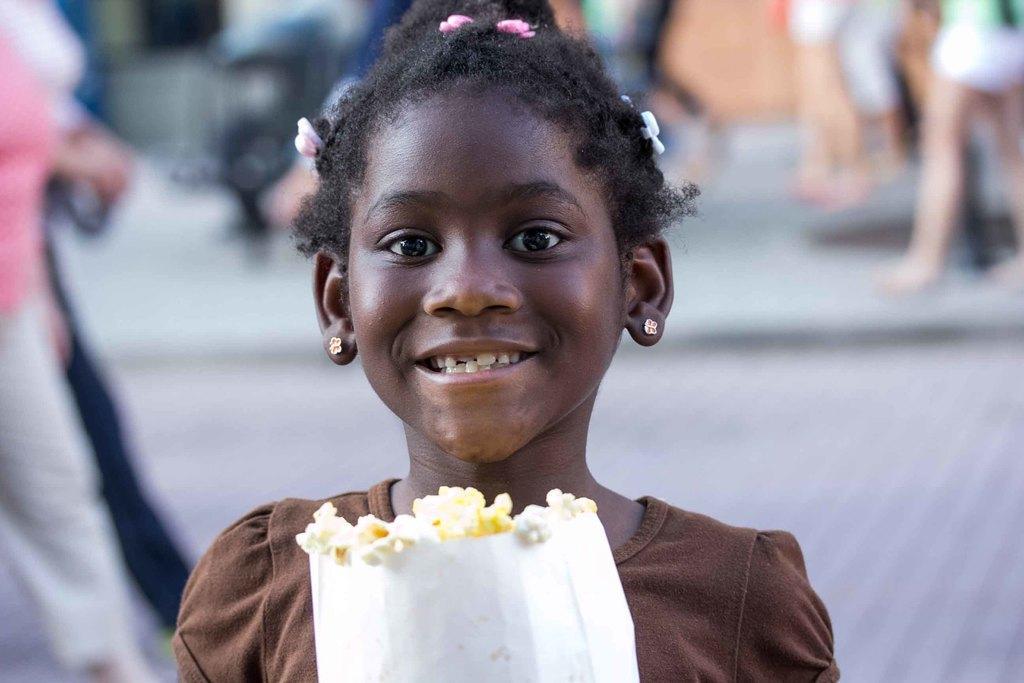How would you summarize this image in a sentence or two? In the middle of the image a girl is standing, smiling and holding popcorn. Behind her few people are walking. Background of the image is blur. 